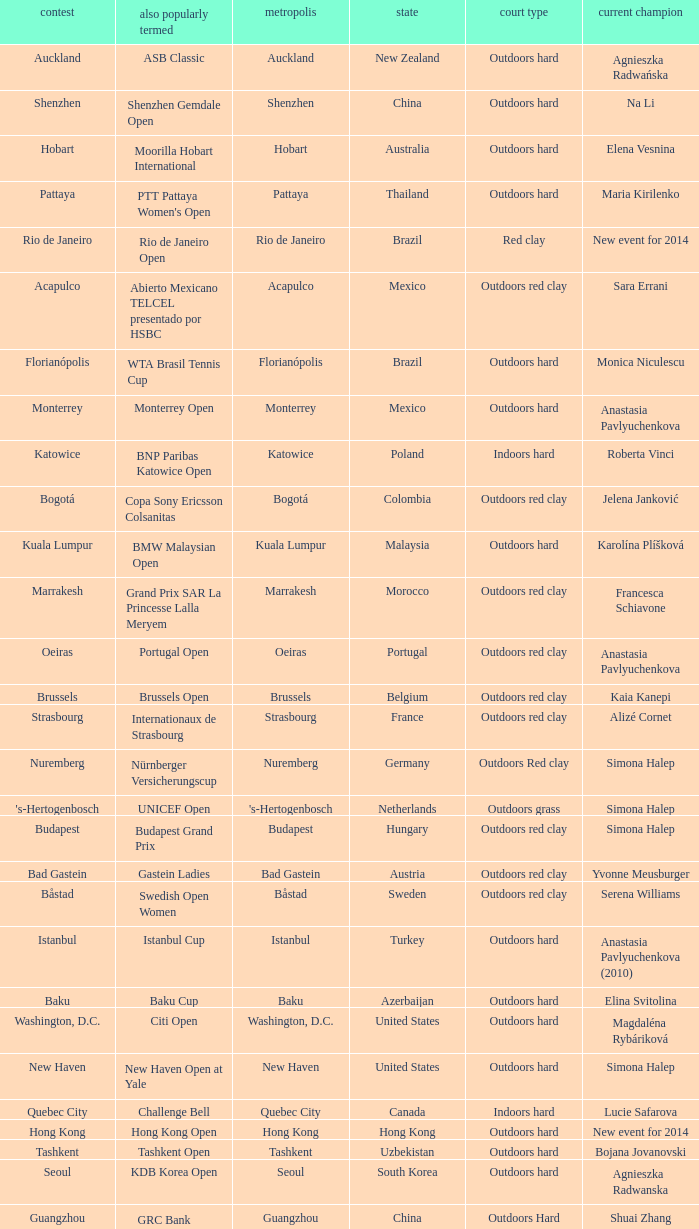How many defending champs from thailand? 1.0. Can you parse all the data within this table? {'header': ['contest', 'also popularly termed', 'metropolis', 'state', 'court type', 'current champion'], 'rows': [['Auckland', 'ASB Classic', 'Auckland', 'New Zealand', 'Outdoors hard', 'Agnieszka Radwańska'], ['Shenzhen', 'Shenzhen Gemdale Open', 'Shenzhen', 'China', 'Outdoors hard', 'Na Li'], ['Hobart', 'Moorilla Hobart International', 'Hobart', 'Australia', 'Outdoors hard', 'Elena Vesnina'], ['Pattaya', "PTT Pattaya Women's Open", 'Pattaya', 'Thailand', 'Outdoors hard', 'Maria Kirilenko'], ['Rio de Janeiro', 'Rio de Janeiro Open', 'Rio de Janeiro', 'Brazil', 'Red clay', 'New event for 2014'], ['Acapulco', 'Abierto Mexicano TELCEL presentado por HSBC', 'Acapulco', 'Mexico', 'Outdoors red clay', 'Sara Errani'], ['Florianópolis', 'WTA Brasil Tennis Cup', 'Florianópolis', 'Brazil', 'Outdoors hard', 'Monica Niculescu'], ['Monterrey', 'Monterrey Open', 'Monterrey', 'Mexico', 'Outdoors hard', 'Anastasia Pavlyuchenkova'], ['Katowice', 'BNP Paribas Katowice Open', 'Katowice', 'Poland', 'Indoors hard', 'Roberta Vinci'], ['Bogotá', 'Copa Sony Ericsson Colsanitas', 'Bogotá', 'Colombia', 'Outdoors red clay', 'Jelena Janković'], ['Kuala Lumpur', 'BMW Malaysian Open', 'Kuala Lumpur', 'Malaysia', 'Outdoors hard', 'Karolína Plíšková'], ['Marrakesh', 'Grand Prix SAR La Princesse Lalla Meryem', 'Marrakesh', 'Morocco', 'Outdoors red clay', 'Francesca Schiavone'], ['Oeiras', 'Portugal Open', 'Oeiras', 'Portugal', 'Outdoors red clay', 'Anastasia Pavlyuchenkova'], ['Brussels', 'Brussels Open', 'Brussels', 'Belgium', 'Outdoors red clay', 'Kaia Kanepi'], ['Strasbourg', 'Internationaux de Strasbourg', 'Strasbourg', 'France', 'Outdoors red clay', 'Alizé Cornet'], ['Nuremberg', 'Nürnberger Versicherungscup', 'Nuremberg', 'Germany', 'Outdoors Red clay', 'Simona Halep'], ["'s-Hertogenbosch", 'UNICEF Open', "'s-Hertogenbosch", 'Netherlands', 'Outdoors grass', 'Simona Halep'], ['Budapest', 'Budapest Grand Prix', 'Budapest', 'Hungary', 'Outdoors red clay', 'Simona Halep'], ['Bad Gastein', 'Gastein Ladies', 'Bad Gastein', 'Austria', 'Outdoors red clay', 'Yvonne Meusburger'], ['Båstad', 'Swedish Open Women', 'Båstad', 'Sweden', 'Outdoors red clay', 'Serena Williams'], ['Istanbul', 'Istanbul Cup', 'Istanbul', 'Turkey', 'Outdoors hard', 'Anastasia Pavlyuchenkova (2010)'], ['Baku', 'Baku Cup', 'Baku', 'Azerbaijan', 'Outdoors hard', 'Elina Svitolina'], ['Washington, D.C.', 'Citi Open', 'Washington, D.C.', 'United States', 'Outdoors hard', 'Magdaléna Rybáriková'], ['New Haven', 'New Haven Open at Yale', 'New Haven', 'United States', 'Outdoors hard', 'Simona Halep'], ['Quebec City', 'Challenge Bell', 'Quebec City', 'Canada', 'Indoors hard', 'Lucie Safarova'], ['Hong Kong', 'Hong Kong Open', 'Hong Kong', 'Hong Kong', 'Outdoors hard', 'New event for 2014'], ['Tashkent', 'Tashkent Open', 'Tashkent', 'Uzbekistan', 'Outdoors hard', 'Bojana Jovanovski'], ['Seoul', 'KDB Korea Open', 'Seoul', 'South Korea', 'Outdoors hard', 'Agnieszka Radwanska'], ['Guangzhou', "GRC Bank Guangzhou International Women's Open", 'Guangzhou', 'China', 'Outdoors Hard', 'Shuai Zhang'], ['Linz', 'Generali Ladies Linz', 'Linz', 'Austria', 'Indoors hard', 'Angelique Kerber'], ['Osaka', 'HP Open', 'Osaka', 'Japan', 'Outdoors hard', 'Samantha Stosur'], ['Luxembourg', 'BGL Luxembourg Open', 'Luxembourg City', 'Luxembourg', 'Indoors hard', 'Caroline Wozniacki']]} 